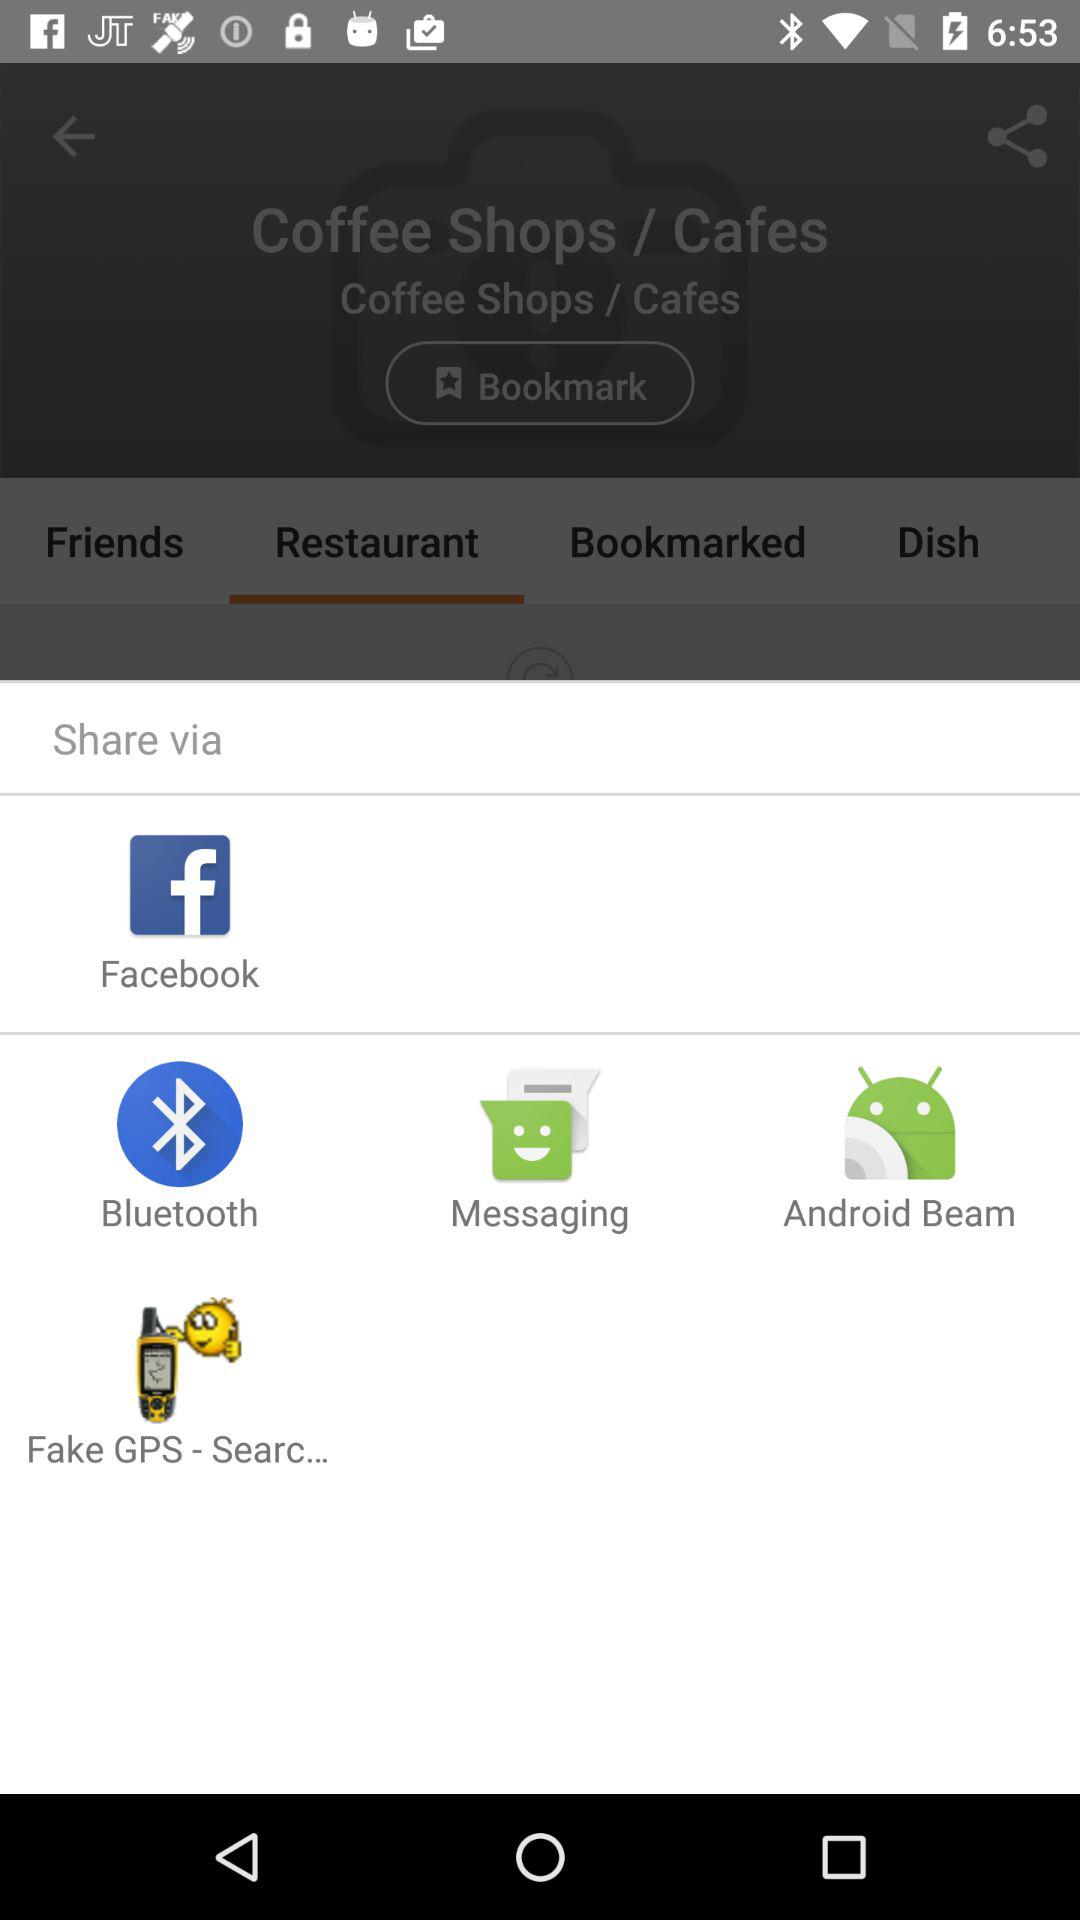Which applications can be used to share? The applications that can be used to share are "Facebook", "Bluetooth", "Messaging", "Android Beam" and "Fake GPS - Searc...". 